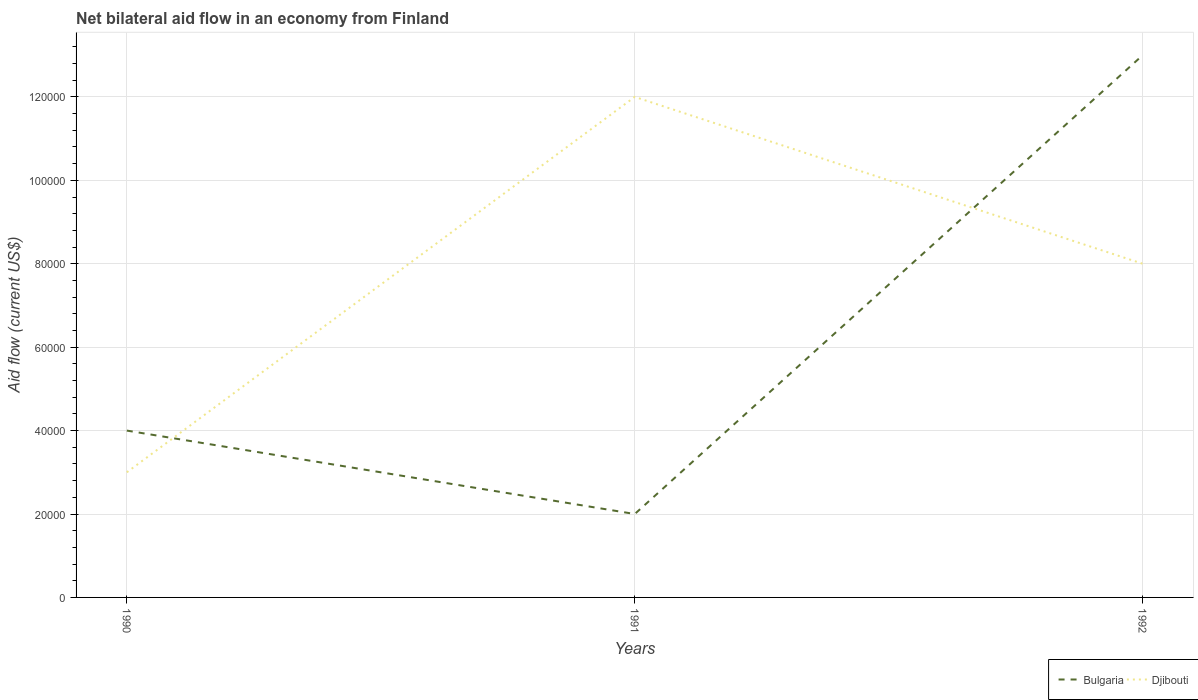How many different coloured lines are there?
Provide a succinct answer. 2. Does the line corresponding to Djibouti intersect with the line corresponding to Bulgaria?
Your answer should be compact. Yes. Across all years, what is the maximum net bilateral aid flow in Djibouti?
Give a very brief answer. 3.00e+04. What is the total net bilateral aid flow in Bulgaria in the graph?
Keep it short and to the point. 2.00e+04. What is the difference between the highest and the second highest net bilateral aid flow in Bulgaria?
Make the answer very short. 1.10e+05. Is the net bilateral aid flow in Djibouti strictly greater than the net bilateral aid flow in Bulgaria over the years?
Your answer should be very brief. No. How many years are there in the graph?
Provide a short and direct response. 3. Does the graph contain any zero values?
Offer a terse response. No. How are the legend labels stacked?
Offer a terse response. Horizontal. What is the title of the graph?
Provide a short and direct response. Net bilateral aid flow in an economy from Finland. Does "United Kingdom" appear as one of the legend labels in the graph?
Your answer should be very brief. No. What is the label or title of the X-axis?
Your answer should be very brief. Years. What is the label or title of the Y-axis?
Make the answer very short. Aid flow (current US$). What is the Aid flow (current US$) of Djibouti in 1990?
Give a very brief answer. 3.00e+04. What is the Aid flow (current US$) in Djibouti in 1991?
Keep it short and to the point. 1.20e+05. Across all years, what is the maximum Aid flow (current US$) of Djibouti?
Offer a very short reply. 1.20e+05. Across all years, what is the minimum Aid flow (current US$) of Bulgaria?
Give a very brief answer. 2.00e+04. Across all years, what is the minimum Aid flow (current US$) in Djibouti?
Give a very brief answer. 3.00e+04. What is the total Aid flow (current US$) of Bulgaria in the graph?
Offer a terse response. 1.90e+05. What is the total Aid flow (current US$) of Djibouti in the graph?
Ensure brevity in your answer.  2.30e+05. What is the difference between the Aid flow (current US$) in Djibouti in 1990 and that in 1991?
Your response must be concise. -9.00e+04. What is the difference between the Aid flow (current US$) in Djibouti in 1990 and that in 1992?
Offer a terse response. -5.00e+04. What is the difference between the Aid flow (current US$) of Djibouti in 1991 and that in 1992?
Offer a very short reply. 4.00e+04. What is the difference between the Aid flow (current US$) of Bulgaria in 1990 and the Aid flow (current US$) of Djibouti in 1991?
Provide a short and direct response. -8.00e+04. What is the average Aid flow (current US$) of Bulgaria per year?
Provide a succinct answer. 6.33e+04. What is the average Aid flow (current US$) in Djibouti per year?
Offer a very short reply. 7.67e+04. In the year 1991, what is the difference between the Aid flow (current US$) in Bulgaria and Aid flow (current US$) in Djibouti?
Provide a short and direct response. -1.00e+05. What is the ratio of the Aid flow (current US$) of Bulgaria in 1990 to that in 1992?
Make the answer very short. 0.31. What is the ratio of the Aid flow (current US$) of Bulgaria in 1991 to that in 1992?
Provide a short and direct response. 0.15. What is the difference between the highest and the lowest Aid flow (current US$) in Djibouti?
Provide a short and direct response. 9.00e+04. 